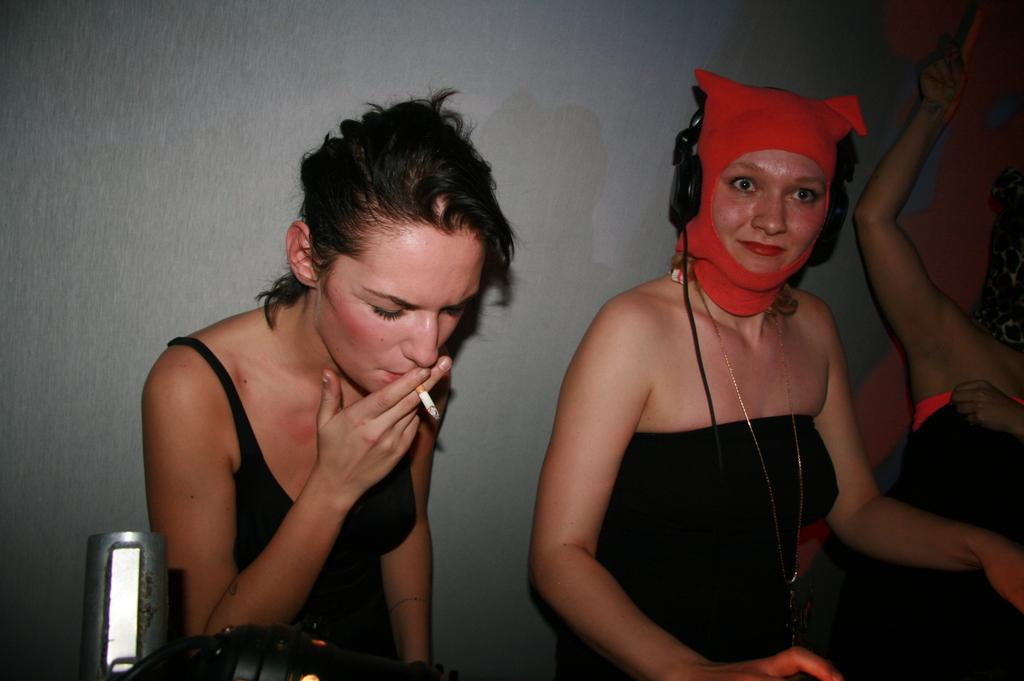How many women are present in the image? There are three women in the image. What is one of the women doing in the image? One of the women is smoking a cigarette. What can be seen in front of the women? There is some equipment in front of the women. What is located behind the women? There is a wall behind the women. Where is the shelf located in the image? There is no shelf present in the image. Can you see any fish in the image? There are no fish visible in the image. 